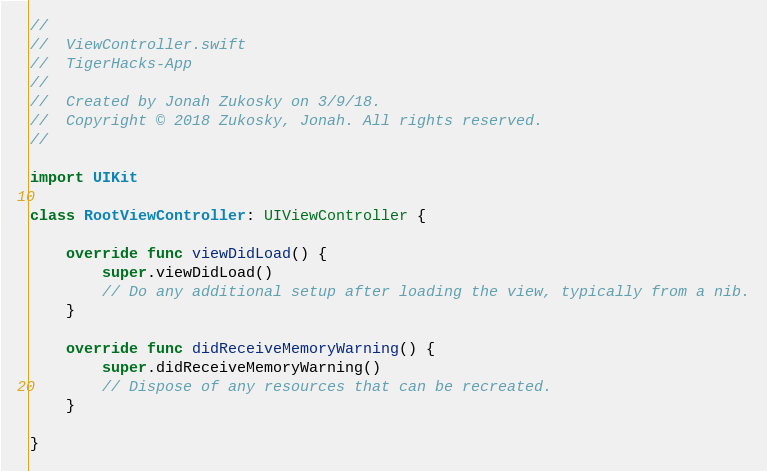Convert code to text. <code><loc_0><loc_0><loc_500><loc_500><_Swift_>//
//  ViewController.swift
//  TigerHacks-App
//
//  Created by Jonah Zukosky on 3/9/18.
//  Copyright © 2018 Zukosky, Jonah. All rights reserved.
//

import UIKit

class RootViewController: UIViewController {

    override func viewDidLoad() {
        super.viewDidLoad()
        // Do any additional setup after loading the view, typically from a nib.
    }

    override func didReceiveMemoryWarning() {
        super.didReceiveMemoryWarning()
        // Dispose of any resources that can be recreated.
    }

}
</code> 